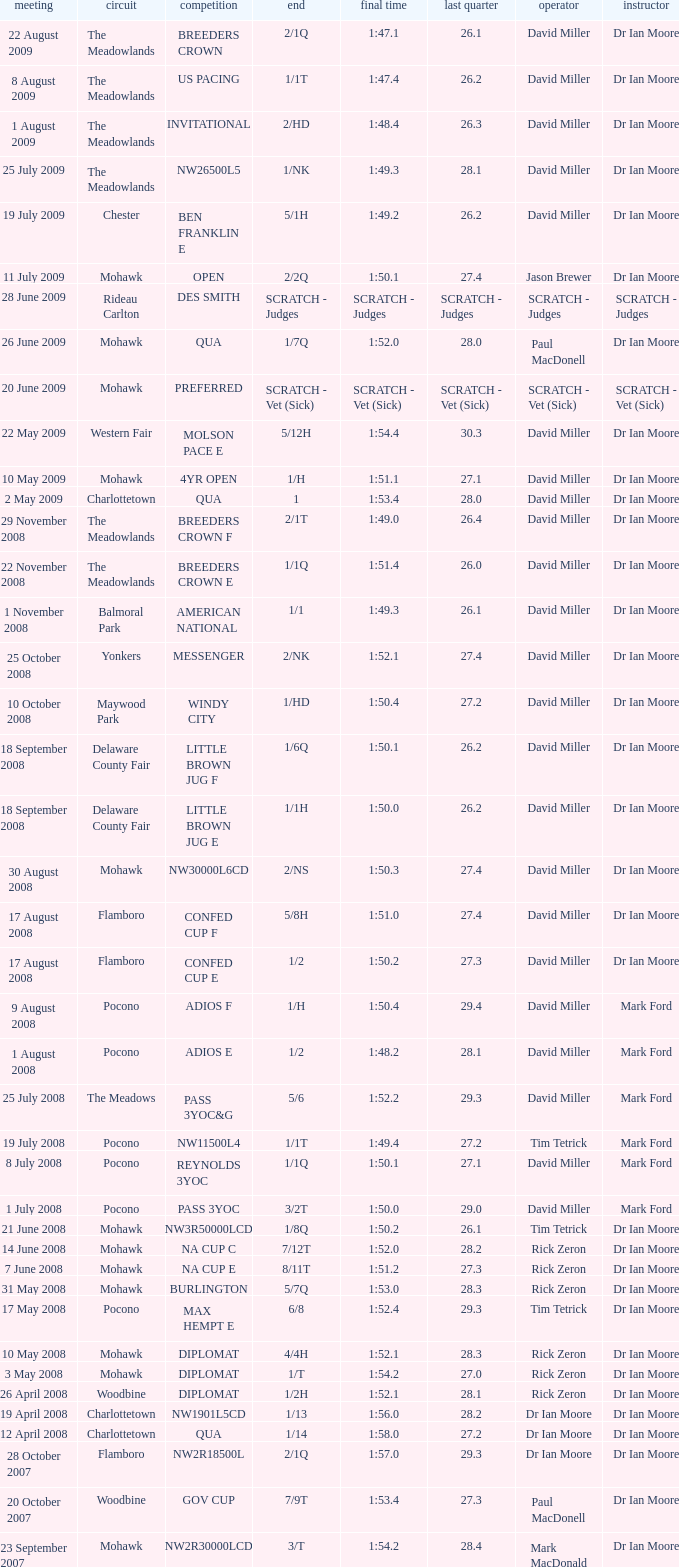Would you be able to parse every entry in this table? {'header': ['meeting', 'circuit', 'competition', 'end', 'final time', 'last quarter', 'operator', 'instructor'], 'rows': [['22 August 2009', 'The Meadowlands', 'BREEDERS CROWN', '2/1Q', '1:47.1', '26.1', 'David Miller', 'Dr Ian Moore'], ['8 August 2009', 'The Meadowlands', 'US PACING', '1/1T', '1:47.4', '26.2', 'David Miller', 'Dr Ian Moore'], ['1 August 2009', 'The Meadowlands', 'INVITATIONAL', '2/HD', '1:48.4', '26.3', 'David Miller', 'Dr Ian Moore'], ['25 July 2009', 'The Meadowlands', 'NW26500L5', '1/NK', '1:49.3', '28.1', 'David Miller', 'Dr Ian Moore'], ['19 July 2009', 'Chester', 'BEN FRANKLIN E', '5/1H', '1:49.2', '26.2', 'David Miller', 'Dr Ian Moore'], ['11 July 2009', 'Mohawk', 'OPEN', '2/2Q', '1:50.1', '27.4', 'Jason Brewer', 'Dr Ian Moore'], ['28 June 2009', 'Rideau Carlton', 'DES SMITH', 'SCRATCH - Judges', 'SCRATCH - Judges', 'SCRATCH - Judges', 'SCRATCH - Judges', 'SCRATCH - Judges'], ['26 June 2009', 'Mohawk', 'QUA', '1/7Q', '1:52.0', '28.0', 'Paul MacDonell', 'Dr Ian Moore'], ['20 June 2009', 'Mohawk', 'PREFERRED', 'SCRATCH - Vet (Sick)', 'SCRATCH - Vet (Sick)', 'SCRATCH - Vet (Sick)', 'SCRATCH - Vet (Sick)', 'SCRATCH - Vet (Sick)'], ['22 May 2009', 'Western Fair', 'MOLSON PACE E', '5/12H', '1:54.4', '30.3', 'David Miller', 'Dr Ian Moore'], ['10 May 2009', 'Mohawk', '4YR OPEN', '1/H', '1:51.1', '27.1', 'David Miller', 'Dr Ian Moore'], ['2 May 2009', 'Charlottetown', 'QUA', '1', '1:53.4', '28.0', 'David Miller', 'Dr Ian Moore'], ['29 November 2008', 'The Meadowlands', 'BREEDERS CROWN F', '2/1T', '1:49.0', '26.4', 'David Miller', 'Dr Ian Moore'], ['22 November 2008', 'The Meadowlands', 'BREEDERS CROWN E', '1/1Q', '1:51.4', '26.0', 'David Miller', 'Dr Ian Moore'], ['1 November 2008', 'Balmoral Park', 'AMERICAN NATIONAL', '1/1', '1:49.3', '26.1', 'David Miller', 'Dr Ian Moore'], ['25 October 2008', 'Yonkers', 'MESSENGER', '2/NK', '1:52.1', '27.4', 'David Miller', 'Dr Ian Moore'], ['10 October 2008', 'Maywood Park', 'WINDY CITY', '1/HD', '1:50.4', '27.2', 'David Miller', 'Dr Ian Moore'], ['18 September 2008', 'Delaware County Fair', 'LITTLE BROWN JUG F', '1/6Q', '1:50.1', '26.2', 'David Miller', 'Dr Ian Moore'], ['18 September 2008', 'Delaware County Fair', 'LITTLE BROWN JUG E', '1/1H', '1:50.0', '26.2', 'David Miller', 'Dr Ian Moore'], ['30 August 2008', 'Mohawk', 'NW30000L6CD', '2/NS', '1:50.3', '27.4', 'David Miller', 'Dr Ian Moore'], ['17 August 2008', 'Flamboro', 'CONFED CUP F', '5/8H', '1:51.0', '27.4', 'David Miller', 'Dr Ian Moore'], ['17 August 2008', 'Flamboro', 'CONFED CUP E', '1/2', '1:50.2', '27.3', 'David Miller', 'Dr Ian Moore'], ['9 August 2008', 'Pocono', 'ADIOS F', '1/H', '1:50.4', '29.4', 'David Miller', 'Mark Ford'], ['1 August 2008', 'Pocono', 'ADIOS E', '1/2', '1:48.2', '28.1', 'David Miller', 'Mark Ford'], ['25 July 2008', 'The Meadows', 'PASS 3YOC&G', '5/6', '1:52.2', '29.3', 'David Miller', 'Mark Ford'], ['19 July 2008', 'Pocono', 'NW11500L4', '1/1T', '1:49.4', '27.2', 'Tim Tetrick', 'Mark Ford'], ['8 July 2008', 'Pocono', 'REYNOLDS 3YOC', '1/1Q', '1:50.1', '27.1', 'David Miller', 'Mark Ford'], ['1 July 2008', 'Pocono', 'PASS 3YOC', '3/2T', '1:50.0', '29.0', 'David Miller', 'Mark Ford'], ['21 June 2008', 'Mohawk', 'NW3R50000LCD', '1/8Q', '1:50.2', '26.1', 'Tim Tetrick', 'Dr Ian Moore'], ['14 June 2008', 'Mohawk', 'NA CUP C', '7/12T', '1:52.0', '28.2', 'Rick Zeron', 'Dr Ian Moore'], ['7 June 2008', 'Mohawk', 'NA CUP E', '8/11T', '1:51.2', '27.3', 'Rick Zeron', 'Dr Ian Moore'], ['31 May 2008', 'Mohawk', 'BURLINGTON', '5/7Q', '1:53.0', '28.3', 'Rick Zeron', 'Dr Ian Moore'], ['17 May 2008', 'Pocono', 'MAX HEMPT E', '6/8', '1:52.4', '29.3', 'Tim Tetrick', 'Dr Ian Moore'], ['10 May 2008', 'Mohawk', 'DIPLOMAT', '4/4H', '1:52.1', '28.3', 'Rick Zeron', 'Dr Ian Moore'], ['3 May 2008', 'Mohawk', 'DIPLOMAT', '1/T', '1:54.2', '27.0', 'Rick Zeron', 'Dr Ian Moore'], ['26 April 2008', 'Woodbine', 'DIPLOMAT', '1/2H', '1:52.1', '28.1', 'Rick Zeron', 'Dr Ian Moore'], ['19 April 2008', 'Charlottetown', 'NW1901L5CD', '1/13', '1:56.0', '28.2', 'Dr Ian Moore', 'Dr Ian Moore'], ['12 April 2008', 'Charlottetown', 'QUA', '1/14', '1:58.0', '27.2', 'Dr Ian Moore', 'Dr Ian Moore'], ['28 October 2007', 'Flamboro', 'NW2R18500L', '2/1Q', '1:57.0', '29.3', 'Dr Ian Moore', 'Dr Ian Moore'], ['20 October 2007', 'Woodbine', 'GOV CUP', '7/9T', '1:53.4', '27.3', 'Paul MacDonell', 'Dr Ian Moore'], ['23 September 2007', 'Mohawk', 'NW2R30000LCD', '3/T', '1:54.2', '28.4', 'Mark MacDonald', 'Dr Ian Moore'], ['15 September 2007', 'Mohawk', 'NASAGAWEYA', '8/12T', '1:55.2', '30.3', 'Mark MacDonald', 'Dr Ian Moore'], ['1 September 2007', 'Mohawk', 'METRO F', '6/9T', '1:51.3', '28.2', 'Mark MacDonald', 'Dr Ian Moore'], ['25 August 2007', 'Mohawk', 'METRO E', '3/4', '1:53.0', '28.1', 'Mark MacDonald', 'Dr Ian Moore'], ['19 August 2007', 'Mohawk', 'NW2R22000LCD', '3/1', '1:53.1', '27.2', 'Paul MacDonell', 'Dr Ian Moore'], ['6 August 2007', 'Mohawk', 'DREAM MAKER', '4/2Q', '1:54.1', '28.1', 'Paul MacDonell', 'Dr Ian Moore'], ['30 July 2007', 'Mohawk', 'DREAM MAKER', '2/1T', '1:53.4', '30.0', 'Dr Ian Moore', 'Dr Ian Moore'], ['23 July 2007', 'Mohawk', 'DREAM MAKER', '2/Q', '1:54.0', '27.4', 'Paul MacDonell', 'Dr Ian Moore'], ['15 July 2007', 'Mohawk', '2YR-C-COND', '1/H', '1:57.2', '27.3', 'Dr Ian Moore', 'Dr Ian Moore'], ['30 June 2007', 'Charlottetown', 'NW2RLFTCD', '1/4H', '1:58.0', '28.1', 'Dr Ian Moore', 'Dr Ian Moore'], ['21 June 2007', 'Charlottetown', 'NW1RLFT', '1/4H', '2:02.3', '29.4', 'Dr Ian Moore', 'Dr Ian Moore'], ['14 June 2007', 'Charlottetown', 'QUA', '1/5H', '2:03.1', '29.2', 'Dr Ian Moore', 'Dr Ian Moore']]} What is the finishing time with a 2/1q finish on the Meadowlands track? 1:47.1. 